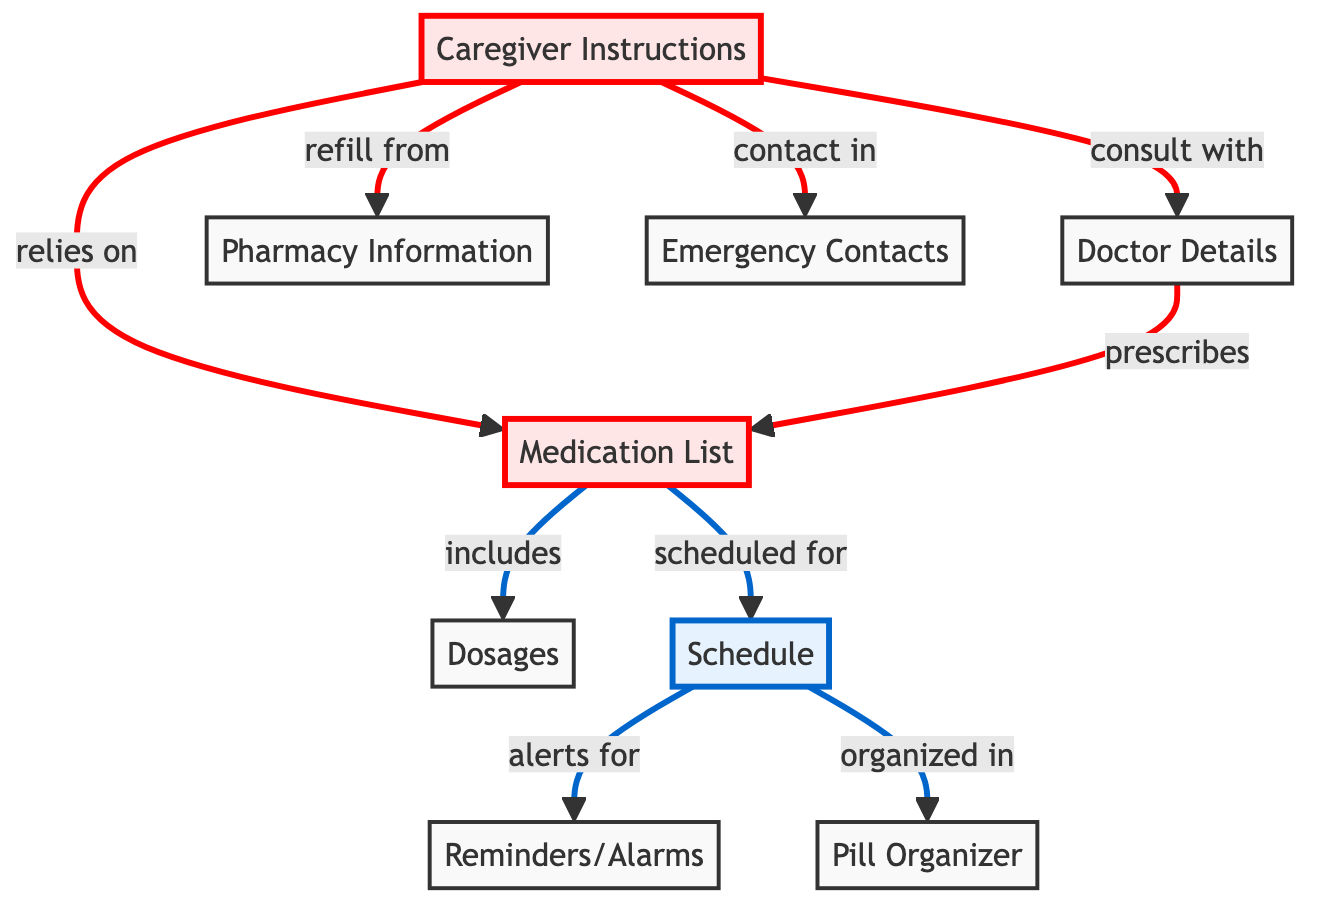What is the first node in the diagram? The first node is titled "Medication List," which is the starting point for organizing medications in the diagram.
Answer: Medication List How many important nodes are there in the diagram? There are three important nodes: "Medication List," "Caregiver Instructions," and "Doctor Details." Counting these nodes gives us a total of three important nodes.
Answer: 3 What is the relationship between "Schedule" and "Reminders/Alarms"? The relationship is that "Schedule" alerts for "Reminders/Alarms." This indicates that reminders are based on the medication schedule.
Answer: alerts for What does "Caregiver Instructions" rely on? "Caregiver Instructions" relies on the "Medication List" as it contains the essential information needed for caregiving.
Answer: Medication List How is the "Schedule" organized? The "Schedule" is organized in the "Pill Organizer," which helps to keep track of medication distribution throughout the week.
Answer: Pill Organizer Which node provides contact information for emergencies? The node that provides contact information for emergencies is "Emergency Contacts." This node is crucial for ensuring quick access to contact individuals in case of a medical emergency.
Answer: Emergency Contacts What does "Doctor Details" prescribe? "Doctor Details" prescribes the "Medication List," indicating that the medications listed are determined by the healthcare provider.
Answer: Medication List Which two nodes are connected to the "Caregiver Instructions"? The two nodes connected to "Caregiver Instructions" are "Medication List" and "Doctor Details." This shows that caregiver instructions are based on both medication details and doctor consultations.
Answer: Medication List and Doctor Details What is the purpose of the "Pharmacy Information" node? The "Pharmacy Information" node's purpose is to facilitate medication refills, indicating that details from this node are necessary for maintaining medication supply.
Answer: refill from How many total nodes are present in the diagram? There are a total of nine nodes present in the diagram. By counting each node individually, we confirm this total.
Answer: 9 